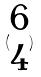Convert formula to latex. <formula><loc_0><loc_0><loc_500><loc_500>( \begin{matrix} 6 \\ 4 \end{matrix} )</formula> 